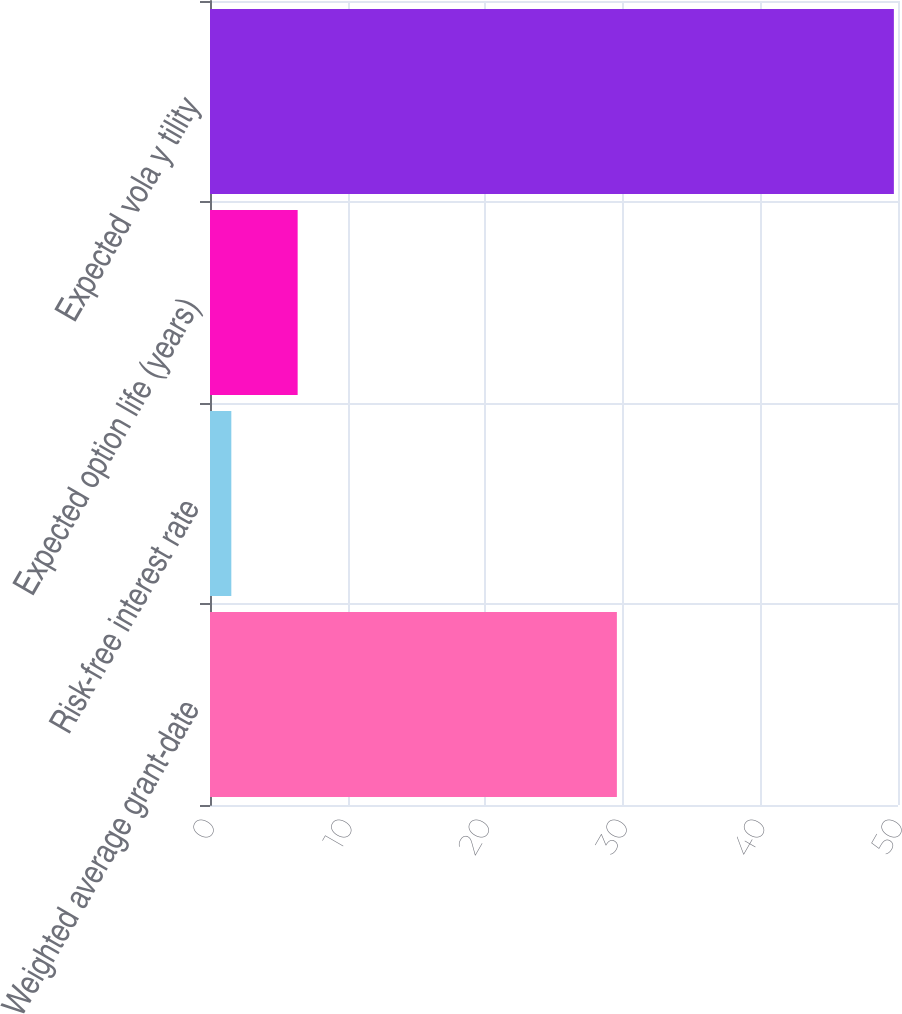Convert chart. <chart><loc_0><loc_0><loc_500><loc_500><bar_chart><fcel>Weighted average grant-date<fcel>Risk-free interest rate<fcel>Expected option life (years)<fcel>Expected vola y tility<nl><fcel>29.57<fcel>1.55<fcel>6.37<fcel>49.7<nl></chart> 